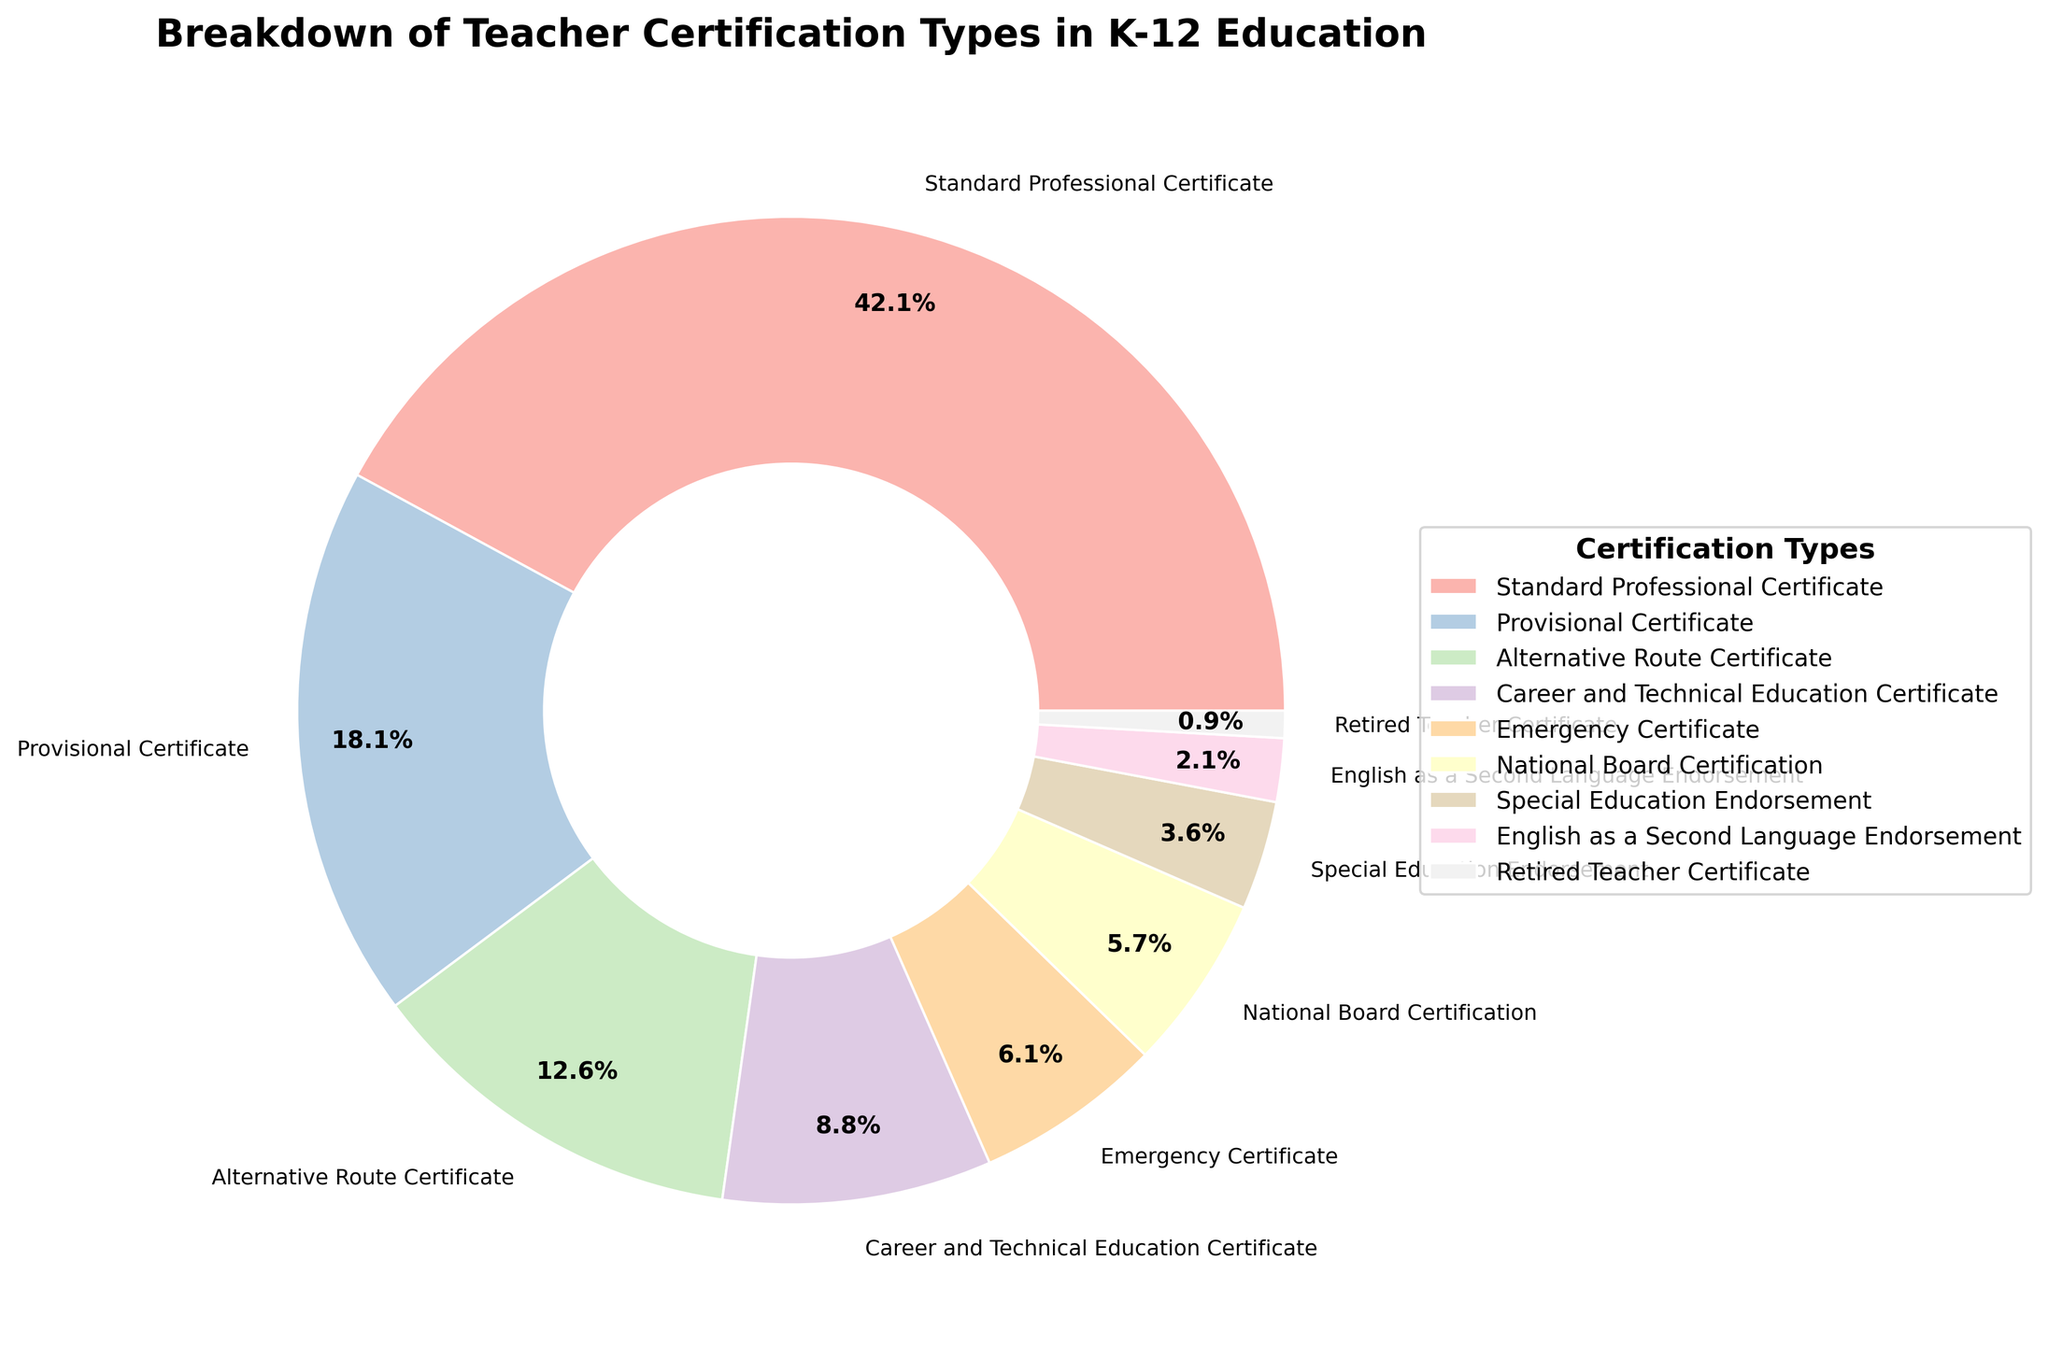Which certification type has the highest percentage? The highest percentage value on the pie chart is labeled as the "Standard Professional Certificate," which is 42.5%.
Answer: Standard Professional Certificate Which two certification types together make up more than half of the chart? The Standard Professional Certificate (42.5%) and Provisional Certificate (18.3%) together sum up to 60.8%, which is more than half of the 100% total.
Answer: Standard Professional Certificate and Provisional Certificate How much more percentage does the Standard Professional Certificate have compared to the National Board Certification? The Standard Professional Certificate has 42.5%, and the National Board Certification has 5.8%. The difference is 42.5% - 5.8% = 36.7%.
Answer: 36.7% What is the sum of the percentages of Alternative Route Certificate and Special Education Endorsement? The pie chart shows Alternative Route Certificate has 12.7% and Special Education Endorsement has 3.6%. Adding them together: 12.7% + 3.6% = 16.3%.
Answer: 16.3% Which certification type has a larger percentage: Career and Technical Education Certificate or English as a Second Language Endorsement? The Career and Technical Education Certificate has 8.9%, whereas the English as a Second Language Endorsement has 2.1%. Comparing the two, 8.9% is larger than 2.1%.
Answer: Career and Technical Education Certificate How many certification types have a percentage lower than 10%? The pie chart segments with percentages below 10% are Provisional Certificate (18.3%), Alternative Route Certificate (12.7%), Career and Technical Education Certificate (8.9%), Emergency Certificate (6.2%), National Board Certification (5.8%), Special Education Endorsement (3.6%), English as a Second Language Endorsement (2.1%), and Retired Teacher Certificate (0.9%). Thus, there are 6 certification types below 10%.
Answer: 6 Compare the combined percentage of Emergency Certificate and Special Education Endorsement to the percentage of Provisional Certificate. Emergency Certificate has 6.2% and Special Education Endorsement has 3.6%. Combined, they are 6.2% + 3.6% = 9.8%, which is less than the Provisional Certificate's 18.3%.
Answer: Less What are the two certification types with the smallest percentages? The smallest percentages in the pie chart belong to Retired Teacher Certificate (0.9%) and English as a Second Language Endorsement (2.1%).
Answer: Retired Teacher Certificate and English as a Second Language Endorsement 